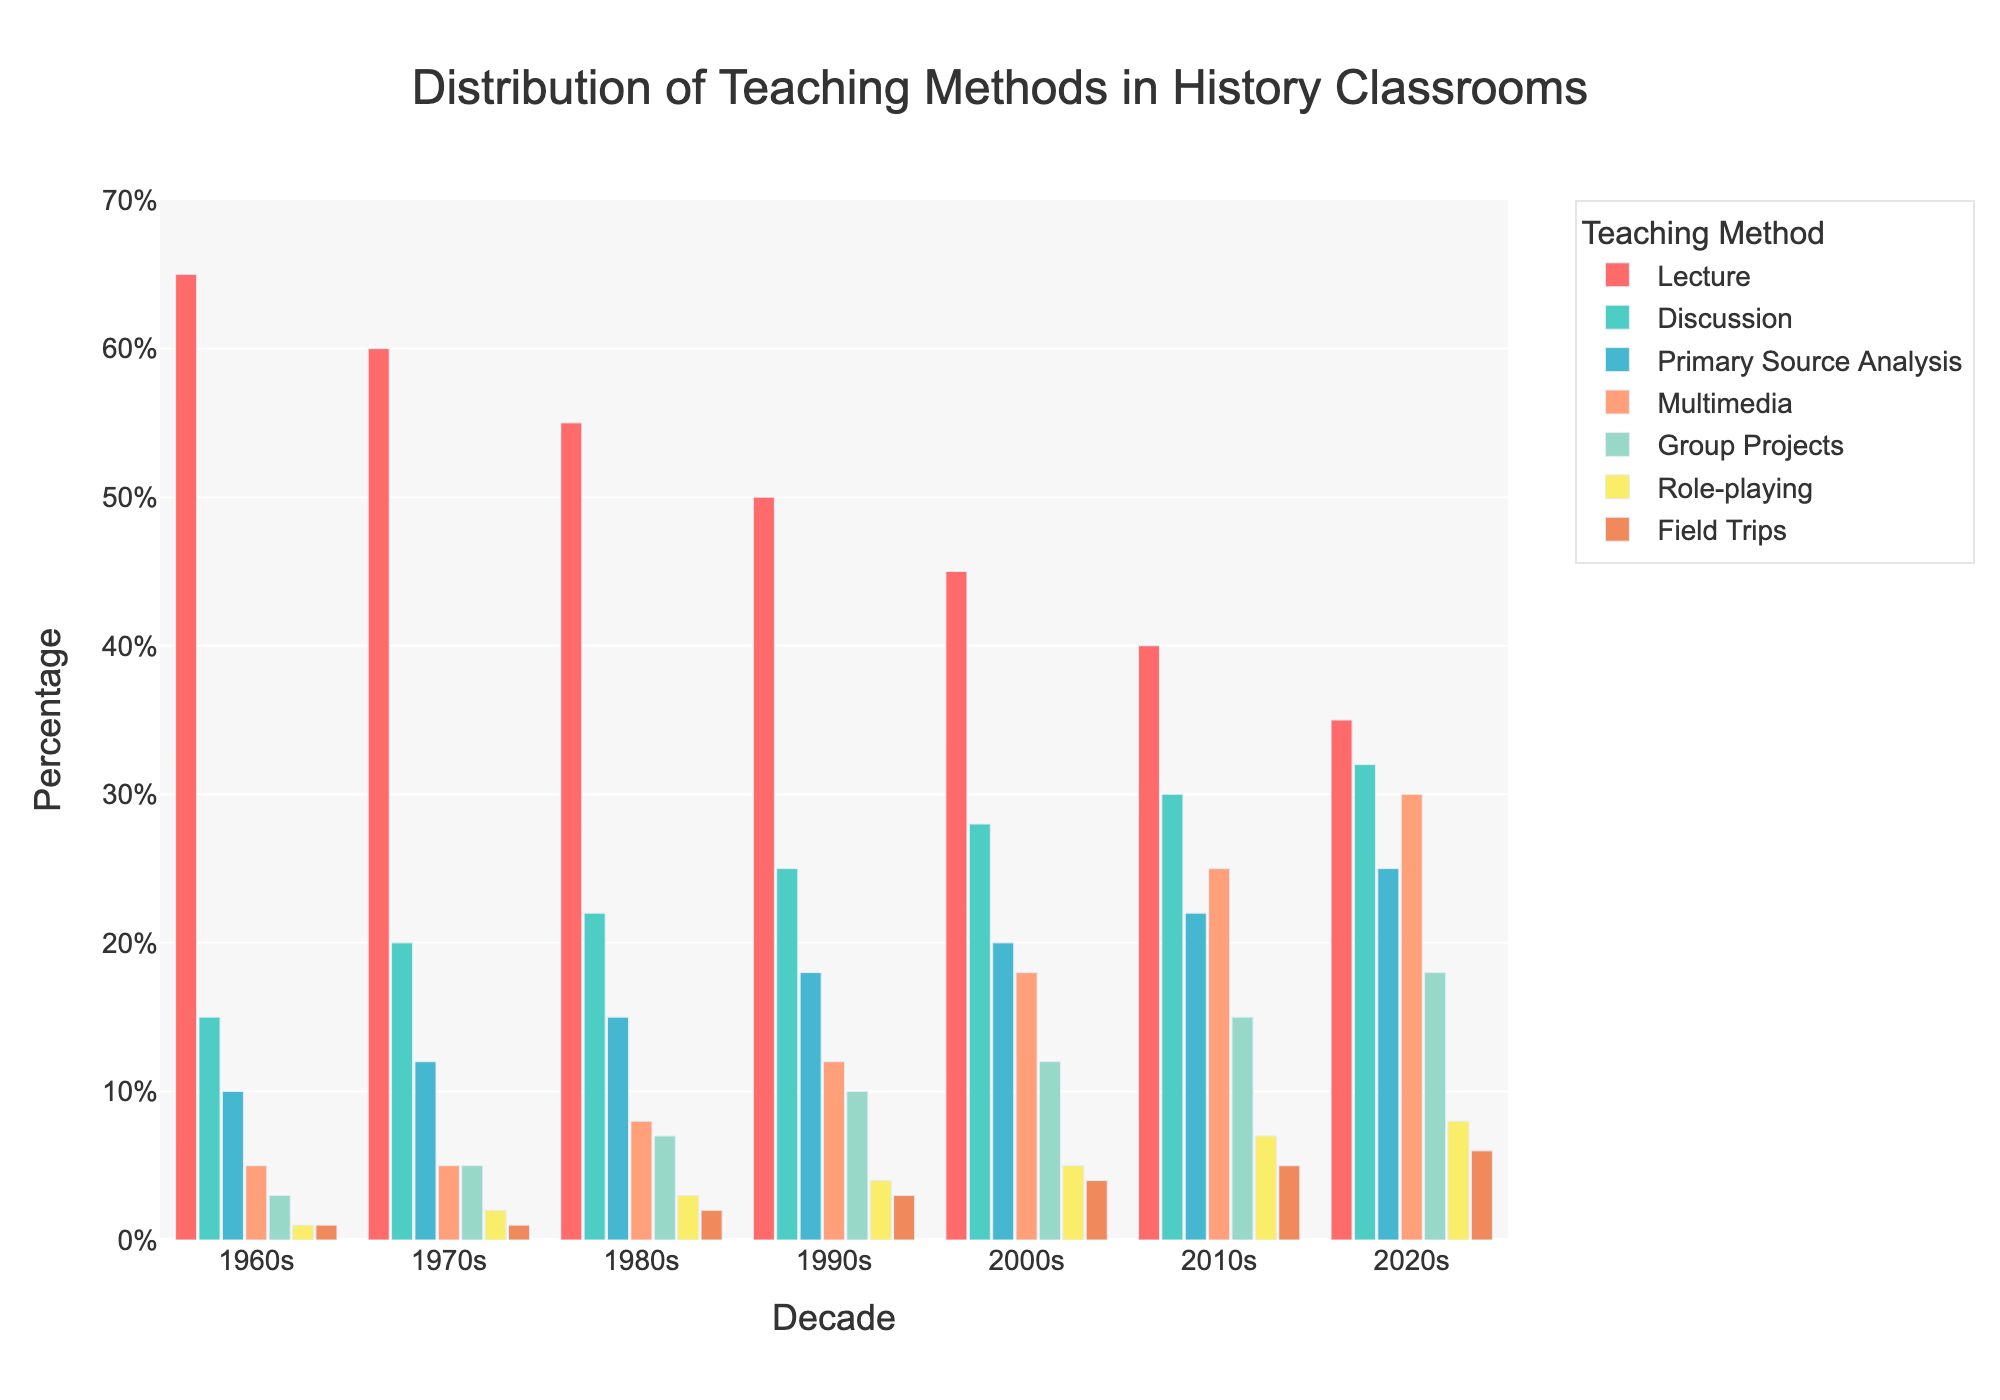What teaching method has the highest percentage in the 1960s? The highest bar in the 1960s is Lecture, which reaches 65%.
Answer: Lecture How does the percentage of Multimedia in the 2020s compare to that in the 2010s? In the 2020s, Multimedia is 30%, and in the 2010s, it is 25%. Comparing the two, 30% is greater than 25%.
Answer: 2020s > 2010s Which decade has the highest percentage for Role-playing? The Role-playing method can be identified by the length of the bars for each decade. The highest bar for Role-playing is in the 2020s at 8%.
Answer: 2020s What is the difference in percentage between Lecture and Group Projects in the 2000s? In the 2000s, Lecture is 45%, and Group Projects are 12%. The difference is 45% - 12% = 33%.
Answer: 33% Which teaching method shows a consistent increase in percentage from the 1960s to the 2020s? By looking at the trend for each teaching method, Primary Source Analysis shows a consistent increase from 10% in the 1960s to 25% in the 2020s.
Answer: Primary Source Analysis What is the total percentage of Lecture and Discussion combined in the 1990s? Lecture is 50%, and Discussion is 25% in the 1990s. The total is 50% + 25% = 75%.
Answer: 75% Which decade has the least utilization of Field Trips? By observing the Field Trips method bars, the 1960s have the lowest bar at 1%.
Answer: 1960s How many teaching methods have a percentage of at least 20% in the 2020s? In the 2020s, Lecture (35%), Discussion (32%), Primary Source Analysis (25%), and Multimedia (30%) all have percentages above 20%. This counts as four teaching methods.
Answer: 4 What is the average percentage of Group Projects from the 1960s to the 2020s? Group Projects percentages are 3, 5, 7, 10, 12, 15, and 18 for each decade. Adding these gives 70, and dividing by 7 decades gives 70 / 7 = 10.
Answer: 10 